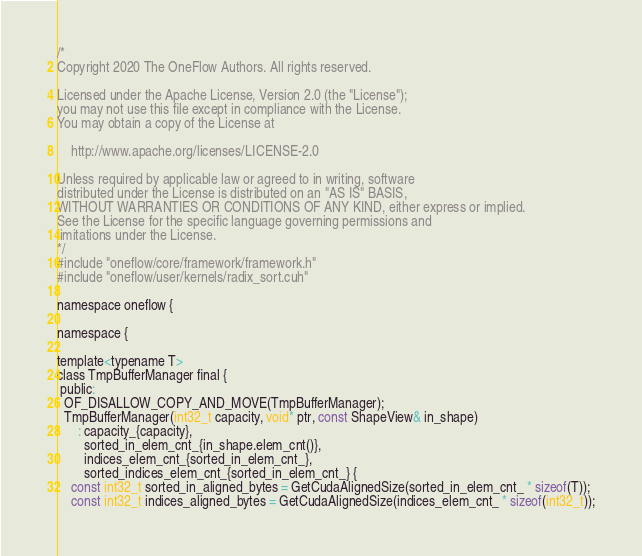<code> <loc_0><loc_0><loc_500><loc_500><_Cuda_>/*
Copyright 2020 The OneFlow Authors. All rights reserved.

Licensed under the Apache License, Version 2.0 (the "License");
you may not use this file except in compliance with the License.
You may obtain a copy of the License at

    http://www.apache.org/licenses/LICENSE-2.0

Unless required by applicable law or agreed to in writing, software
distributed under the License is distributed on an "AS IS" BASIS,
WITHOUT WARRANTIES OR CONDITIONS OF ANY KIND, either express or implied.
See the License for the specific language governing permissions and
limitations under the License.
*/
#include "oneflow/core/framework/framework.h"
#include "oneflow/user/kernels/radix_sort.cuh"

namespace oneflow {

namespace {

template<typename T>
class TmpBufferManager final {
 public:
  OF_DISALLOW_COPY_AND_MOVE(TmpBufferManager);
  TmpBufferManager(int32_t capacity, void* ptr, const ShapeView& in_shape)
      : capacity_{capacity},
        sorted_in_elem_cnt_{in_shape.elem_cnt()},
        indices_elem_cnt_{sorted_in_elem_cnt_},
        sorted_indices_elem_cnt_{sorted_in_elem_cnt_} {
    const int32_t sorted_in_aligned_bytes = GetCudaAlignedSize(sorted_in_elem_cnt_ * sizeof(T));
    const int32_t indices_aligned_bytes = GetCudaAlignedSize(indices_elem_cnt_ * sizeof(int32_t));</code> 